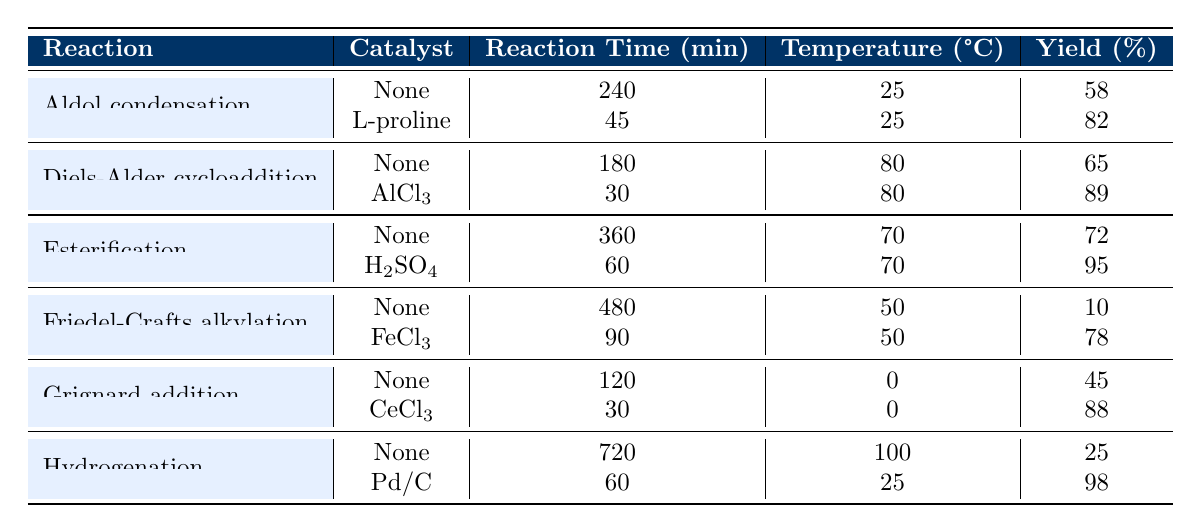What is the reaction time for the Aldol condensation using L-proline? According to the table, the reaction time for Aldol condensation with L-proline is listed as 45 minutes.
Answer: 45 minutes Which reaction had the highest yield and what was its percentage? From the table, the reaction with the highest yield is the Esterification with H2SO4, which has a yield of 95%.
Answer: 95% What is the difference in reaction times between the Friedel-Crafts alkylation with and without a catalyst? The reaction time without a catalyst for Friedel-Crafts alkylation is 480 minutes, while with FeCl3 it's 90 minutes. The difference is 480 - 90 = 390 minutes.
Answer: 390 minutes Is the yield of Grignard addition with CeCl3 higher than the yield of Hydrogenation with Pd/C? The yield for Grignard addition with CeCl3 is 88%, while the yield for Hydrogenation with Pd/C is 98%. Since 88% is less than 98%, the answer is no.
Answer: No What is the average reaction time for uncatalyzed reactions listed in the table? The uncatalyzed reactions and their times are: Aldol condensation (240), Diels-Alder (180), Esterification (360), Friedel-Crafts (480), Grignard addition (120), and Hydrogenation (720). The total sum is 240 + 180 + 360 + 480 + 120 + 720 = 2100. Dividing by the number of reactions (6), the average is 2100/6 = 350 minutes.
Answer: 350 minutes Which catalyst resulted in the lowest reaction time in the table? The lowest reaction time is associated with the Diels-Alder cycloaddition using AlCl3, which takes 30 minutes.
Answer: AlCl3 How much more efficient is the yield of Esterification with H2SO4 compared to uncatalyzed Esterification? The yield of uncatalyzed Esterification is 72%, and with H2SO4 it is 95%. The difference in yield is 95 - 72 = 23%. This signifies a 23% increase in yield with the catalyst.
Answer: 23% increase Which reaction had the longest reaction time overall, and what was that time? The longest reaction time listed in the table is for Hydrogenation without a catalyst, which takes 720 minutes.
Answer: 720 minutes Is there a catalyst used in the Aldol condensation that improves the reaction time compared to the uncatalyzed version? Yes, the Aldol condensation using L-proline has a reaction time of 45 minutes, which is significantly lower than the 240 minutes for no catalyst.
Answer: Yes 